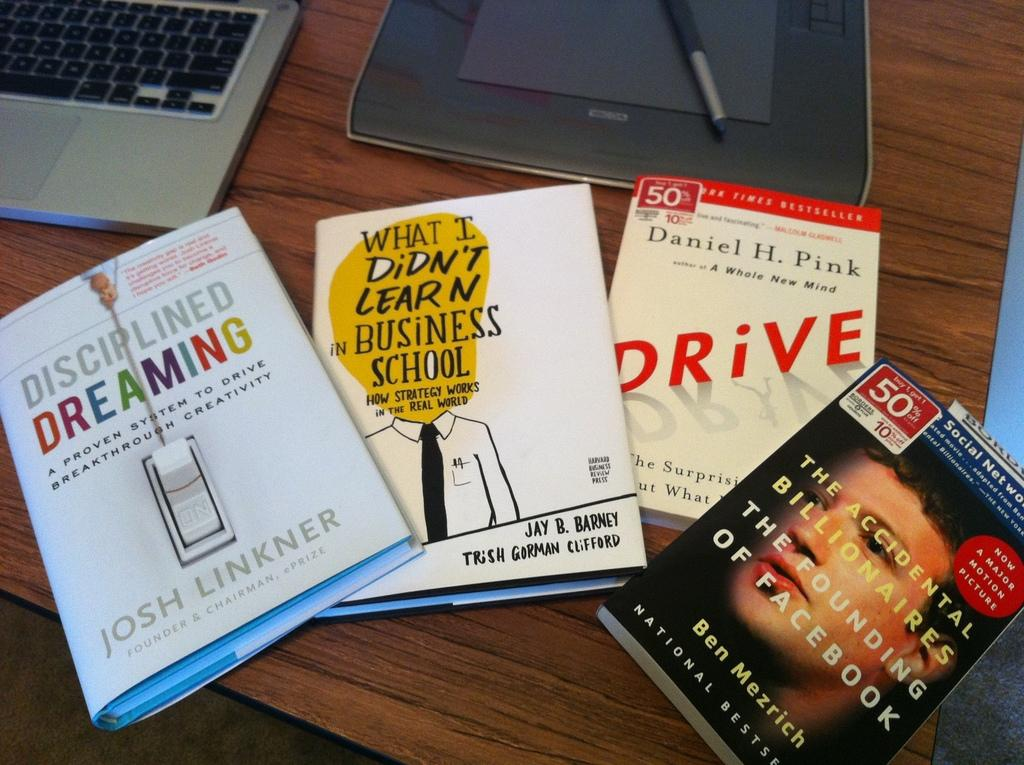<image>
Present a compact description of the photo's key features. Books are on a table including one titled Drive. 